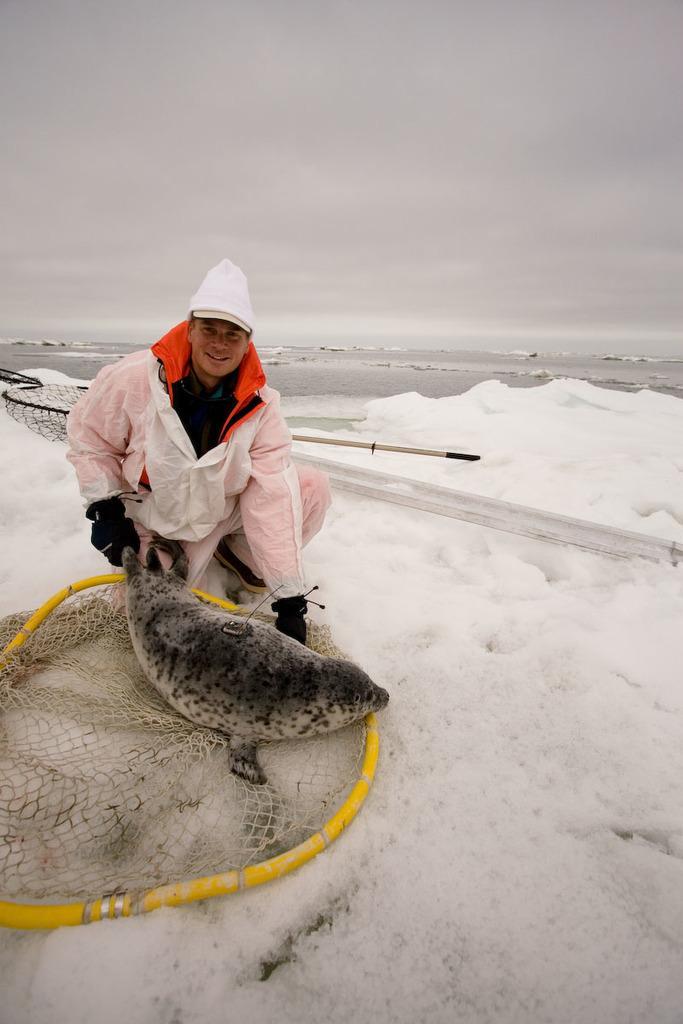Please provide a concise description of this image. In this image man is holding a seal in his hand and smiling. On the ground there is snow, and on the snow there is a net, and the sky is cloudy. 